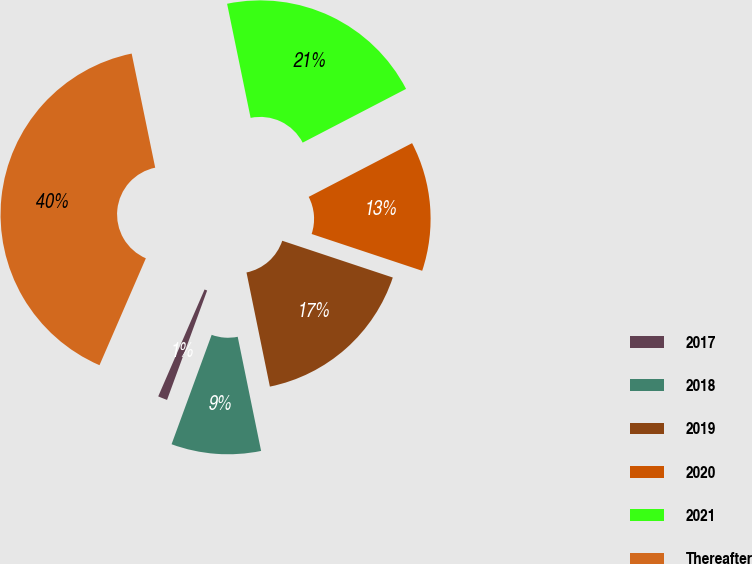<chart> <loc_0><loc_0><loc_500><loc_500><pie_chart><fcel>2017<fcel>2018<fcel>2019<fcel>2020<fcel>2021<fcel>Thereafter<nl><fcel>0.92%<fcel>8.81%<fcel>16.67%<fcel>12.74%<fcel>20.61%<fcel>40.25%<nl></chart> 